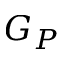Convert formula to latex. <formula><loc_0><loc_0><loc_500><loc_500>G _ { P }</formula> 